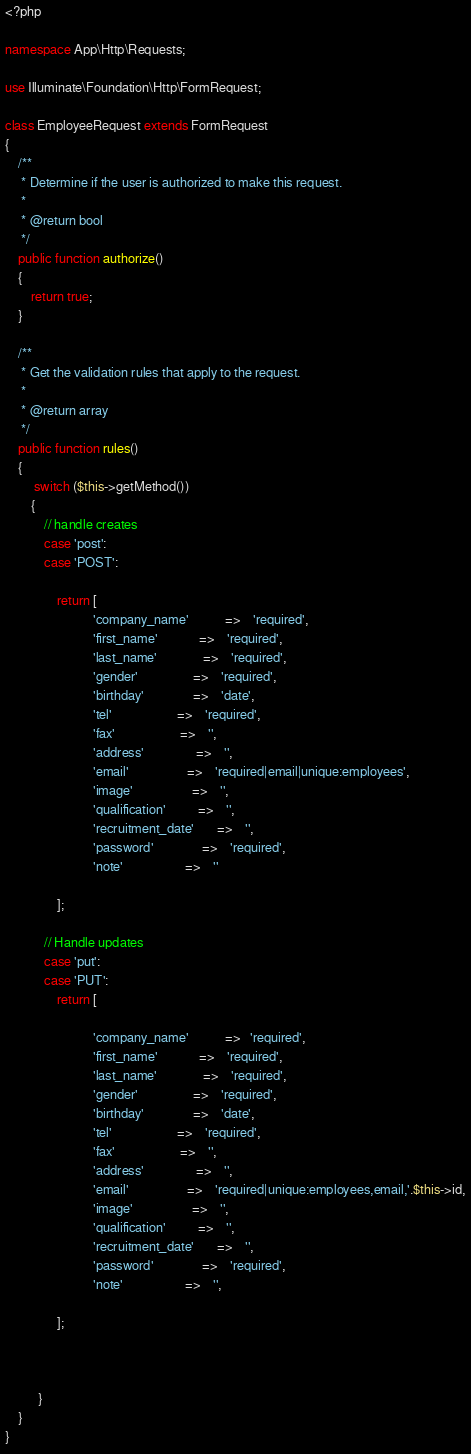Convert code to text. <code><loc_0><loc_0><loc_500><loc_500><_PHP_><?php

namespace App\Http\Requests;

use Illuminate\Foundation\Http\FormRequest;

class EmployeeRequest extends FormRequest
{
    /**
     * Determine if the user is authorized to make this request.
     *
     * @return bool
     */
    public function authorize()
    {
        return true;
    }

    /**
     * Get the validation rules that apply to the request.
     *
     * @return array
     */
    public function rules()
    {
         switch ($this->getMethod())
        {
            // handle creates
            case 'post':
            case 'POST':
           
                return [
                           'company_name'           =>    'required',
                           'first_name'             =>    'required',
                           'last_name'              =>    'required',
                           'gender'                 =>    'required',
                           'birthday'               =>    'date',
                           'tel'                    =>    'required',
                           'fax'                    =>    '',
                           'address'                =>    '',
                           'email'                  =>    'required|email|unique:employees',
                           'image'                  =>    '',
                           'qualification'          =>    '',
                           'recruitment_date'       =>    '',
                           'password'               =>    'required',
                           'note'                   =>    ''

                ];

            // Handle updates
            case 'put':
            case 'PUT':
                return [
                  
                           'company_name'           =>   'required',
                           'first_name'             =>    'required',
                           'last_name'              =>    'required',
                           'gender'                 =>    'required',
                           'birthday'               =>    'date',
                           'tel'                    =>    'required',
                           'fax'                    =>    '',
                           'address'                =>    '',
                           'email'                  =>    'required|unique:employees,email,'.$this->id,
                           'image'                  =>    '',
                           'qualification'          =>    '',
                           'recruitment_date'       =>    '',
                           'password'               =>    'required',
                           'note'                   =>    '',
                         
                ];

           
           
          }
    }
}
</code> 